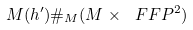Convert formula to latex. <formula><loc_0><loc_0><loc_500><loc_500>M ( h ^ { \prime } ) \# _ { M } ( M \times \ F F P ^ { 2 } )</formula> 